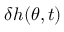Convert formula to latex. <formula><loc_0><loc_0><loc_500><loc_500>\delta h ( \theta , t )</formula> 